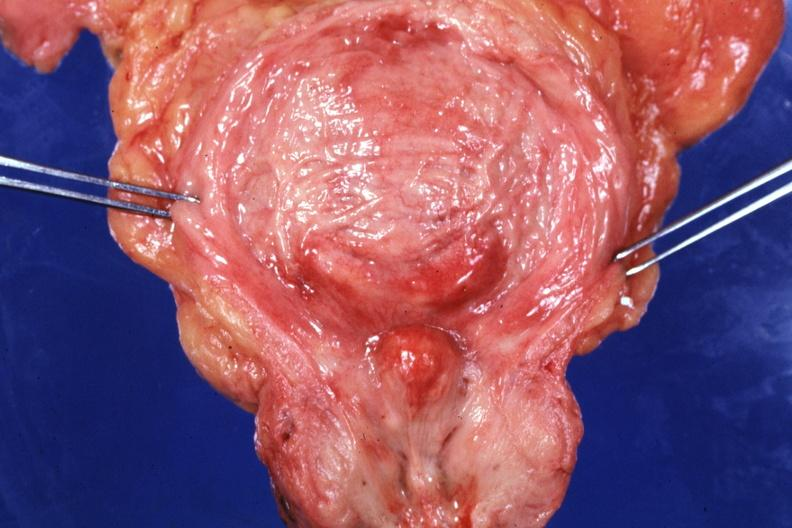what had increase bladder trabeculations very good slide?
Answer the question using a single word or phrase. Opened with median lobe protruding into trigone area also 